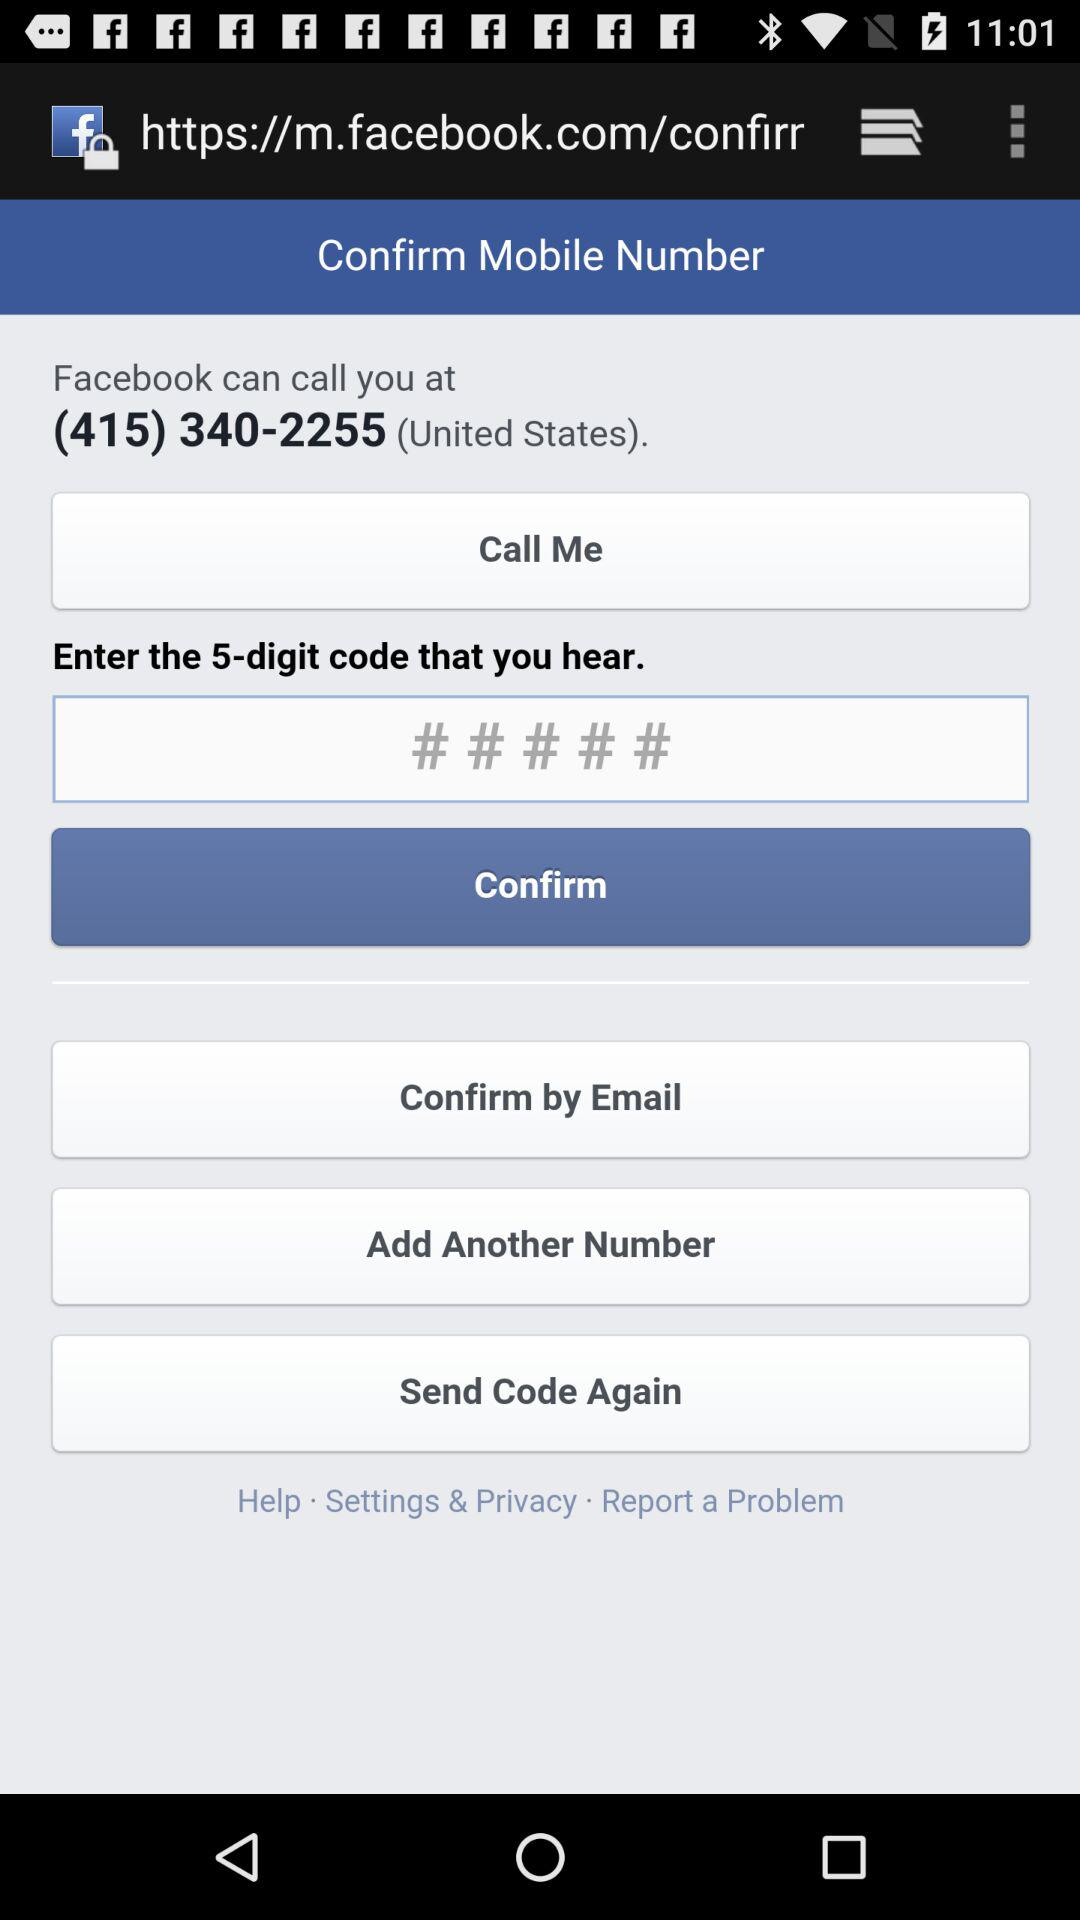How many different ways can I confirm my mobile number?
Answer the question using a single word or phrase. 3 